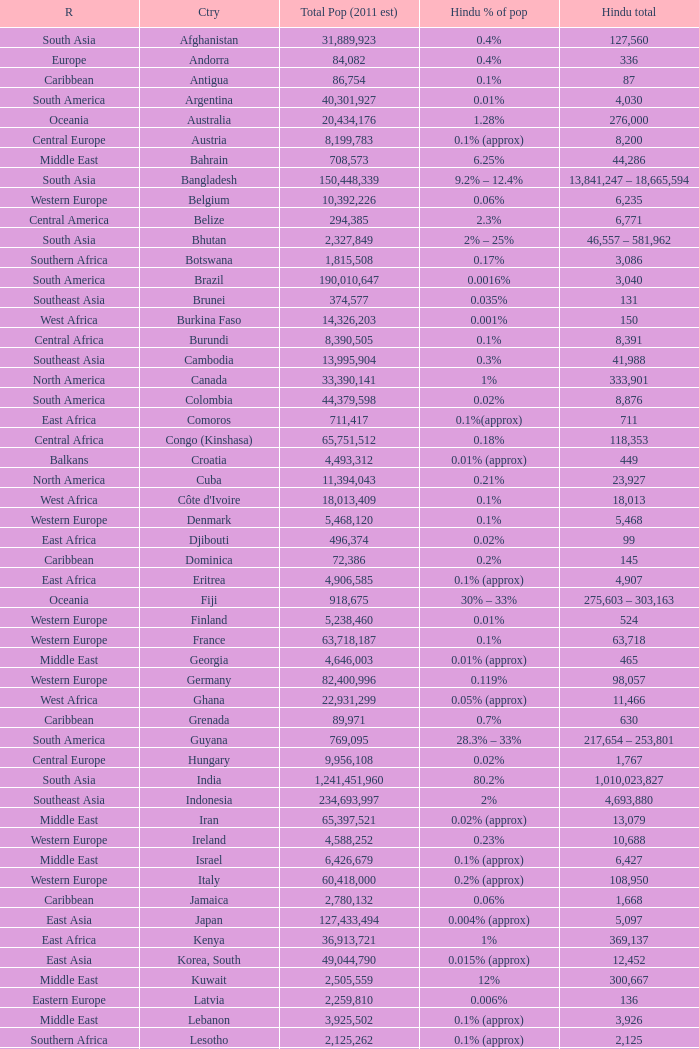Would you be able to parse every entry in this table? {'header': ['R', 'Ctry', 'Total Pop (2011 est)', 'Hindu % of pop', 'Hindu total'], 'rows': [['South Asia', 'Afghanistan', '31,889,923', '0.4%', '127,560'], ['Europe', 'Andorra', '84,082', '0.4%', '336'], ['Caribbean', 'Antigua', '86,754', '0.1%', '87'], ['South America', 'Argentina', '40,301,927', '0.01%', '4,030'], ['Oceania', 'Australia', '20,434,176', '1.28%', '276,000'], ['Central Europe', 'Austria', '8,199,783', '0.1% (approx)', '8,200'], ['Middle East', 'Bahrain', '708,573', '6.25%', '44,286'], ['South Asia', 'Bangladesh', '150,448,339', '9.2% – 12.4%', '13,841,247 – 18,665,594'], ['Western Europe', 'Belgium', '10,392,226', '0.06%', '6,235'], ['Central America', 'Belize', '294,385', '2.3%', '6,771'], ['South Asia', 'Bhutan', '2,327,849', '2% – 25%', '46,557 – 581,962'], ['Southern Africa', 'Botswana', '1,815,508', '0.17%', '3,086'], ['South America', 'Brazil', '190,010,647', '0.0016%', '3,040'], ['Southeast Asia', 'Brunei', '374,577', '0.035%', '131'], ['West Africa', 'Burkina Faso', '14,326,203', '0.001%', '150'], ['Central Africa', 'Burundi', '8,390,505', '0.1%', '8,391'], ['Southeast Asia', 'Cambodia', '13,995,904', '0.3%', '41,988'], ['North America', 'Canada', '33,390,141', '1%', '333,901'], ['South America', 'Colombia', '44,379,598', '0.02%', '8,876'], ['East Africa', 'Comoros', '711,417', '0.1%(approx)', '711'], ['Central Africa', 'Congo (Kinshasa)', '65,751,512', '0.18%', '118,353'], ['Balkans', 'Croatia', '4,493,312', '0.01% (approx)', '449'], ['North America', 'Cuba', '11,394,043', '0.21%', '23,927'], ['West Africa', "Côte d'Ivoire", '18,013,409', '0.1%', '18,013'], ['Western Europe', 'Denmark', '5,468,120', '0.1%', '5,468'], ['East Africa', 'Djibouti', '496,374', '0.02%', '99'], ['Caribbean', 'Dominica', '72,386', '0.2%', '145'], ['East Africa', 'Eritrea', '4,906,585', '0.1% (approx)', '4,907'], ['Oceania', 'Fiji', '918,675', '30% – 33%', '275,603 – 303,163'], ['Western Europe', 'Finland', '5,238,460', '0.01%', '524'], ['Western Europe', 'France', '63,718,187', '0.1%', '63,718'], ['Middle East', 'Georgia', '4,646,003', '0.01% (approx)', '465'], ['Western Europe', 'Germany', '82,400,996', '0.119%', '98,057'], ['West Africa', 'Ghana', '22,931,299', '0.05% (approx)', '11,466'], ['Caribbean', 'Grenada', '89,971', '0.7%', '630'], ['South America', 'Guyana', '769,095', '28.3% – 33%', '217,654 – 253,801'], ['Central Europe', 'Hungary', '9,956,108', '0.02%', '1,767'], ['South Asia', 'India', '1,241,451,960', '80.2%', '1,010,023,827'], ['Southeast Asia', 'Indonesia', '234,693,997', '2%', '4,693,880'], ['Middle East', 'Iran', '65,397,521', '0.02% (approx)', '13,079'], ['Western Europe', 'Ireland', '4,588,252', '0.23%', '10,688'], ['Middle East', 'Israel', '6,426,679', '0.1% (approx)', '6,427'], ['Western Europe', 'Italy', '60,418,000', '0.2% (approx)', '108,950'], ['Caribbean', 'Jamaica', '2,780,132', '0.06%', '1,668'], ['East Asia', 'Japan', '127,433,494', '0.004% (approx)', '5,097'], ['East Africa', 'Kenya', '36,913,721', '1%', '369,137'], ['East Asia', 'Korea, South', '49,044,790', '0.015% (approx)', '12,452'], ['Middle East', 'Kuwait', '2,505,559', '12%', '300,667'], ['Eastern Europe', 'Latvia', '2,259,810', '0.006%', '136'], ['Middle East', 'Lebanon', '3,925,502', '0.1% (approx)', '3,926'], ['Southern Africa', 'Lesotho', '2,125,262', '0.1% (approx)', '2,125'], ['West Africa', 'Liberia', '3,195,931', '0.1% (approx)', '3,196'], ['North Africa', 'Libya', '6,036,914', '0.1%', '6,037'], ['Western Europe', 'Luxembourg', '480,222', '0.07% (approx)', '336'], ['Southern Africa', 'Madagascar', '19,448,815', '0.1%', '19,449'], ['Southern Africa', 'Malawi', '13,603,181', '0.02% – 0.2%', '2,721 – 2,726'], ['Southeast Asia', 'Malaysia', '28,401,017', '7%', '1,630,000'], ['South Asia', 'Maldives', '369,031', '0.01%', '37'], ['Southern Africa', 'Mauritius', '1,250,882', '48% – 50%', '600,423 – 625,441'], ['Eastern Europe', 'Moldova', '4,328,816', '0.01% (approx)', '433'], ['Southern Africa', 'Mozambique', '20,905,585', '0.05% – 0.2%', '10,453 – 41,811'], ['Southeast Asia', 'Myanmar', '47,963,012', '1.5%', '893,000'], ['South Asia', 'Nepal', '28,901,790', '80.6% – 81%', '23,294,843 – 23,410,450'], ['Western Europe', 'Netherlands', '16,570,613', '0.58% – 1.20%', '96,110 – 200,000'], ['Oceania', 'New Zealand', '4,115,771', '1%', '41,158'], ['Western Europe', 'Norway', '4,627,926', '0.5%', '23,140'], ['Middle East', 'Oman', '3,204,897', '3% – 5.7%', '96,147 – 182,679'], ['South Asia', 'Pakistan', '164,741,924', '1.5% – 3.3%', '5,900,000 – 9,000,000'], ['Central America', 'Panama', '3,242,173', '0.3%', '9,726'], ['Southeast Asia', 'Philippines', '98,215,000', '2% (approx)', '2,000,000'], ['Western Europe', 'Portugal', '10,642,836', '0.07%', '7,396'], ['Caribbean', 'Puerto Rico', '3,944,259', '0.09%', '3,550'], ['Middle East', 'Qatar', '907,229', '7.2%', '65,320'], ['East Africa', 'Réunion', '827,000', '6.7%', '55,409'], ['Eastern Europe', 'Russia', '141,377,752', '0.043%', '60,792'], ['Middle East', 'Saudi Arabia', '27,601,038', '0.6% – 1.1%', '165,606 – 303,611'], ['East Africa', 'Seychelles', '81,895', '2%', '1,638'], ['West Africa', 'Sierra Leone', '6,144,562', '0.04% – 0.1%', '2,458 – 6,145'], ['Southeast Asia', 'Singapore', '4,553,009', '5.1%', '262,120'], ['Central Europe', 'Slovakia', '5,447,502', '0.1% (approx)', '5,448'], ['Central Europe', 'Slovenia', '2,009,245', '0.025% (approx)', '500'], ['Southern Africa', 'South Africa', '49,991,300', '1.9%', '959,000'], ['South Asia', 'Sri Lanka', '20,926,315', '7.1% – 12.1%', '1,485,768 – 3,138,947'], ['South America', 'Suriname', '470,784', '20% – 27.4%', '94,157 – 128,995'], ['Southern Africa', 'Swaziland', '1,133,066', '0.15% – 0.2%', '1,700 – 2,266'], ['Western Europe', 'Sweden', '9,031,088', '0.078% – 0.12%', '7,044 – 10,837'], ['Western Europe', 'Switzerland', '7,554,661', '0.38%', '28,708'], ['East Africa', 'Tanzania', '39,384,223', '0.9%', '354,458'], ['Southeast Asia', 'Thailand', '65,068,149', '0.1%', '2,928'], ['Caribbean', 'Trinidad and Tobago', '1,056,608', '22.5%', '237,737'], ['East Africa', 'Uganda', '30,262,610', '0.2% – 0.8%', '60,525 – 242,101'], ['Middle East', 'United Arab Emirates', '4,444,011', '21.25%', '944,352'], ['Western Europe', 'United Kingdom', '60,776,238', '1.7%', '832,000'], ['North America', 'United States', '307,006,550', '0.4%', '1,204,560'], ['Central Asia', 'Uzbekistan', '27,780,059', '0.01% (approx)', '2,778'], ['Southeast Asia', 'Vietnam', '85,262,356', '0.059%', '50,305'], ['Middle East', 'Yemen', '22,230,531', '0.7%', '155,614'], ['Southern Africa', 'Zambia', '11,477,447', '0.14%', '16,068'], ['Southern Africa', 'Zimbabwe', '12,311,143', '0.1%', '123,111'], ['Total', 'Total', '7,000,000,000', '15.48', '1,083,800,358–1,101,518,322']]} Total Population (2011 est) larger than 30,262,610, and a Hindu total of 63,718 involves what country? France. 